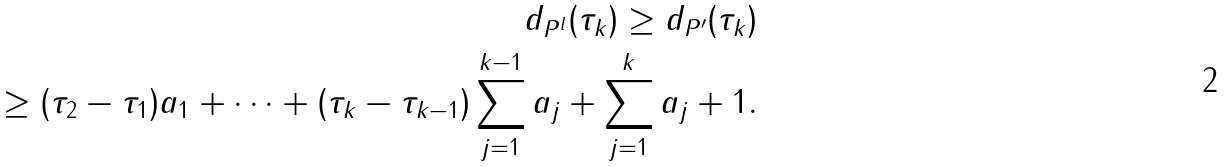Convert formula to latex. <formula><loc_0><loc_0><loc_500><loc_500>d _ { P ^ { l } } ( \tau _ { k } ) \geq d _ { P ^ { \prime } } ( \tau _ { k } ) \\ \geq ( \tau _ { 2 } - \tau _ { 1 } ) a _ { 1 } + \cdots + ( \tau _ { k } - \tau _ { k - 1 } ) \sum _ { j = 1 } ^ { k - 1 } a _ { j } + \sum _ { j = 1 } ^ { k } a _ { j } + 1 .</formula> 